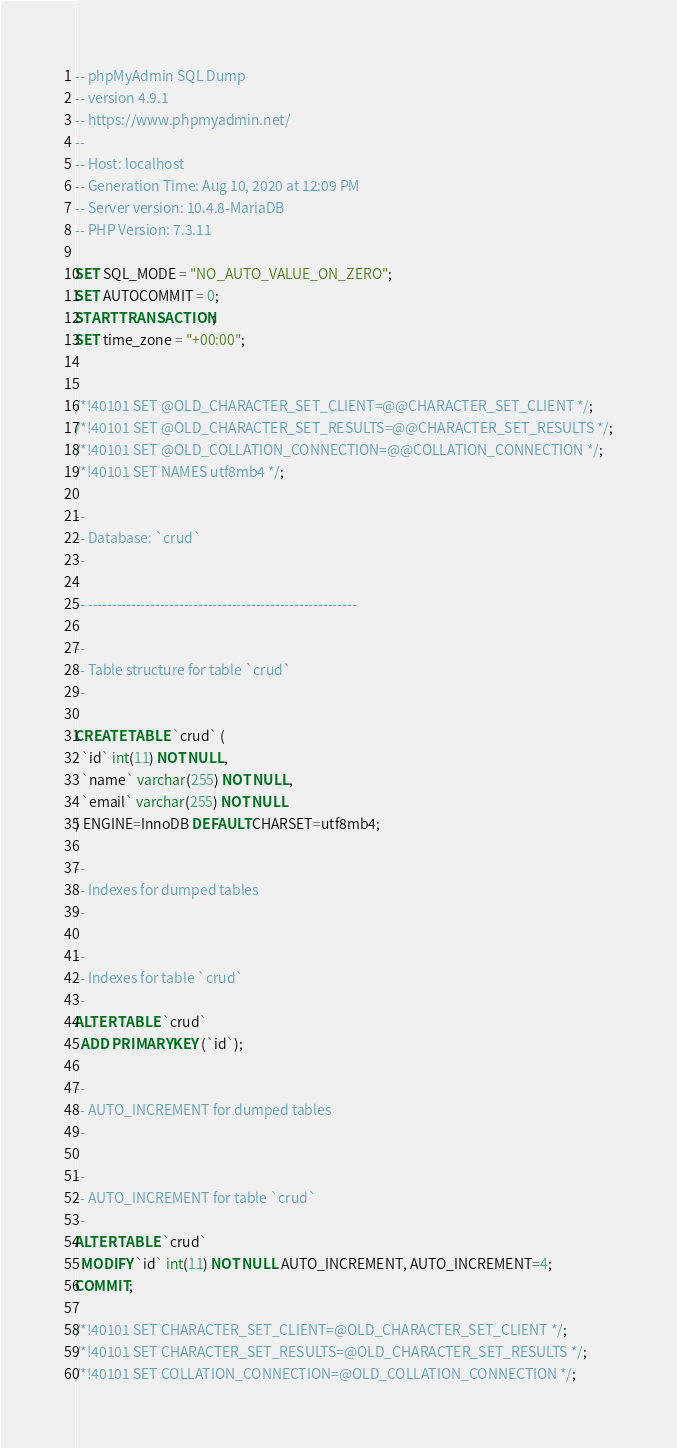Convert code to text. <code><loc_0><loc_0><loc_500><loc_500><_SQL_>-- phpMyAdmin SQL Dump
-- version 4.9.1
-- https://www.phpmyadmin.net/
--
-- Host: localhost
-- Generation Time: Aug 10, 2020 at 12:09 PM
-- Server version: 10.4.8-MariaDB
-- PHP Version: 7.3.11

SET SQL_MODE = "NO_AUTO_VALUE_ON_ZERO";
SET AUTOCOMMIT = 0;
START TRANSACTION;
SET time_zone = "+00:00";


/*!40101 SET @OLD_CHARACTER_SET_CLIENT=@@CHARACTER_SET_CLIENT */;
/*!40101 SET @OLD_CHARACTER_SET_RESULTS=@@CHARACTER_SET_RESULTS */;
/*!40101 SET @OLD_COLLATION_CONNECTION=@@COLLATION_CONNECTION */;
/*!40101 SET NAMES utf8mb4 */;

--
-- Database: `crud`
--

-- --------------------------------------------------------

--
-- Table structure for table `crud`
--

CREATE TABLE `crud` (
  `id` int(11) NOT NULL,
  `name` varchar(255) NOT NULL,
  `email` varchar(255) NOT NULL
) ENGINE=InnoDB DEFAULT CHARSET=utf8mb4;

--
-- Indexes for dumped tables
--

--
-- Indexes for table `crud`
--
ALTER TABLE `crud`
  ADD PRIMARY KEY (`id`);

--
-- AUTO_INCREMENT for dumped tables
--

--
-- AUTO_INCREMENT for table `crud`
--
ALTER TABLE `crud`
  MODIFY `id` int(11) NOT NULL AUTO_INCREMENT, AUTO_INCREMENT=4;
COMMIT;

/*!40101 SET CHARACTER_SET_CLIENT=@OLD_CHARACTER_SET_CLIENT */;
/*!40101 SET CHARACTER_SET_RESULTS=@OLD_CHARACTER_SET_RESULTS */;
/*!40101 SET COLLATION_CONNECTION=@OLD_COLLATION_CONNECTION */;
</code> 